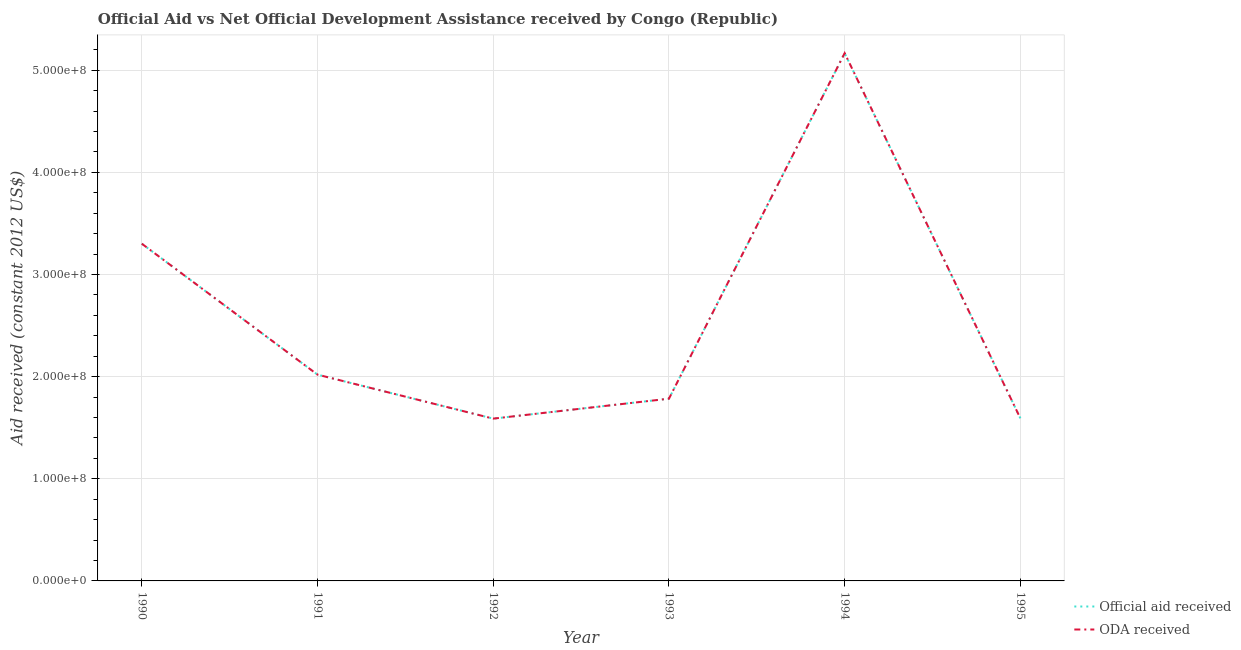Does the line corresponding to oda received intersect with the line corresponding to official aid received?
Ensure brevity in your answer.  Yes. Is the number of lines equal to the number of legend labels?
Offer a terse response. Yes. What is the official aid received in 1992?
Provide a succinct answer. 1.59e+08. Across all years, what is the maximum official aid received?
Keep it short and to the point. 5.17e+08. Across all years, what is the minimum oda received?
Your response must be concise. 1.59e+08. In which year was the official aid received maximum?
Keep it short and to the point. 1994. In which year was the official aid received minimum?
Provide a succinct answer. 1992. What is the total official aid received in the graph?
Ensure brevity in your answer.  1.55e+09. What is the difference between the oda received in 1990 and that in 1991?
Provide a short and direct response. 1.28e+08. What is the difference between the official aid received in 1993 and the oda received in 1990?
Offer a terse response. -1.52e+08. What is the average oda received per year?
Your response must be concise. 2.58e+08. In how many years, is the oda received greater than 300000000 US$?
Offer a terse response. 2. What is the ratio of the oda received in 1990 to that in 1993?
Your answer should be very brief. 1.85. Is the difference between the official aid received in 1990 and 1994 greater than the difference between the oda received in 1990 and 1994?
Offer a terse response. No. What is the difference between the highest and the second highest oda received?
Your answer should be compact. 1.87e+08. What is the difference between the highest and the lowest oda received?
Provide a succinct answer. 3.58e+08. In how many years, is the oda received greater than the average oda received taken over all years?
Your answer should be compact. 2. Is the official aid received strictly less than the oda received over the years?
Ensure brevity in your answer.  No. How many lines are there?
Offer a terse response. 2. Does the graph contain grids?
Offer a very short reply. Yes. How many legend labels are there?
Your answer should be compact. 2. What is the title of the graph?
Give a very brief answer. Official Aid vs Net Official Development Assistance received by Congo (Republic) . Does "Lower secondary rate" appear as one of the legend labels in the graph?
Ensure brevity in your answer.  No. What is the label or title of the Y-axis?
Provide a short and direct response. Aid received (constant 2012 US$). What is the Aid received (constant 2012 US$) in Official aid received in 1990?
Provide a short and direct response. 3.30e+08. What is the Aid received (constant 2012 US$) of ODA received in 1990?
Your response must be concise. 3.30e+08. What is the Aid received (constant 2012 US$) of Official aid received in 1991?
Provide a short and direct response. 2.02e+08. What is the Aid received (constant 2012 US$) of ODA received in 1991?
Keep it short and to the point. 2.02e+08. What is the Aid received (constant 2012 US$) of Official aid received in 1992?
Provide a short and direct response. 1.59e+08. What is the Aid received (constant 2012 US$) of ODA received in 1992?
Offer a terse response. 1.59e+08. What is the Aid received (constant 2012 US$) in Official aid received in 1993?
Provide a short and direct response. 1.78e+08. What is the Aid received (constant 2012 US$) of ODA received in 1993?
Make the answer very short. 1.78e+08. What is the Aid received (constant 2012 US$) of Official aid received in 1994?
Give a very brief answer. 5.17e+08. What is the Aid received (constant 2012 US$) of ODA received in 1994?
Ensure brevity in your answer.  5.17e+08. What is the Aid received (constant 2012 US$) in Official aid received in 1995?
Ensure brevity in your answer.  1.59e+08. What is the Aid received (constant 2012 US$) of ODA received in 1995?
Keep it short and to the point. 1.59e+08. Across all years, what is the maximum Aid received (constant 2012 US$) in Official aid received?
Your response must be concise. 5.17e+08. Across all years, what is the maximum Aid received (constant 2012 US$) in ODA received?
Provide a succinct answer. 5.17e+08. Across all years, what is the minimum Aid received (constant 2012 US$) of Official aid received?
Give a very brief answer. 1.59e+08. Across all years, what is the minimum Aid received (constant 2012 US$) in ODA received?
Make the answer very short. 1.59e+08. What is the total Aid received (constant 2012 US$) in Official aid received in the graph?
Offer a terse response. 1.55e+09. What is the total Aid received (constant 2012 US$) in ODA received in the graph?
Ensure brevity in your answer.  1.55e+09. What is the difference between the Aid received (constant 2012 US$) of Official aid received in 1990 and that in 1991?
Keep it short and to the point. 1.28e+08. What is the difference between the Aid received (constant 2012 US$) in ODA received in 1990 and that in 1991?
Ensure brevity in your answer.  1.28e+08. What is the difference between the Aid received (constant 2012 US$) in Official aid received in 1990 and that in 1992?
Offer a terse response. 1.71e+08. What is the difference between the Aid received (constant 2012 US$) in ODA received in 1990 and that in 1992?
Offer a terse response. 1.71e+08. What is the difference between the Aid received (constant 2012 US$) of Official aid received in 1990 and that in 1993?
Provide a succinct answer. 1.52e+08. What is the difference between the Aid received (constant 2012 US$) of ODA received in 1990 and that in 1993?
Provide a succinct answer. 1.52e+08. What is the difference between the Aid received (constant 2012 US$) in Official aid received in 1990 and that in 1994?
Your answer should be compact. -1.87e+08. What is the difference between the Aid received (constant 2012 US$) in ODA received in 1990 and that in 1994?
Your answer should be very brief. -1.87e+08. What is the difference between the Aid received (constant 2012 US$) in Official aid received in 1990 and that in 1995?
Give a very brief answer. 1.71e+08. What is the difference between the Aid received (constant 2012 US$) of ODA received in 1990 and that in 1995?
Your answer should be very brief. 1.71e+08. What is the difference between the Aid received (constant 2012 US$) of Official aid received in 1991 and that in 1992?
Make the answer very short. 4.31e+07. What is the difference between the Aid received (constant 2012 US$) in ODA received in 1991 and that in 1992?
Offer a very short reply. 4.31e+07. What is the difference between the Aid received (constant 2012 US$) of Official aid received in 1991 and that in 1993?
Provide a short and direct response. 2.35e+07. What is the difference between the Aid received (constant 2012 US$) in ODA received in 1991 and that in 1993?
Give a very brief answer. 2.35e+07. What is the difference between the Aid received (constant 2012 US$) in Official aid received in 1991 and that in 1994?
Offer a very short reply. -3.15e+08. What is the difference between the Aid received (constant 2012 US$) of ODA received in 1991 and that in 1994?
Provide a succinct answer. -3.15e+08. What is the difference between the Aid received (constant 2012 US$) in Official aid received in 1991 and that in 1995?
Provide a short and direct response. 4.28e+07. What is the difference between the Aid received (constant 2012 US$) of ODA received in 1991 and that in 1995?
Ensure brevity in your answer.  4.28e+07. What is the difference between the Aid received (constant 2012 US$) of Official aid received in 1992 and that in 1993?
Keep it short and to the point. -1.95e+07. What is the difference between the Aid received (constant 2012 US$) of ODA received in 1992 and that in 1993?
Keep it short and to the point. -1.95e+07. What is the difference between the Aid received (constant 2012 US$) of Official aid received in 1992 and that in 1994?
Keep it short and to the point. -3.58e+08. What is the difference between the Aid received (constant 2012 US$) in ODA received in 1992 and that in 1994?
Make the answer very short. -3.58e+08. What is the difference between the Aid received (constant 2012 US$) of Official aid received in 1992 and that in 1995?
Your answer should be compact. -2.90e+05. What is the difference between the Aid received (constant 2012 US$) in Official aid received in 1993 and that in 1994?
Provide a short and direct response. -3.38e+08. What is the difference between the Aid received (constant 2012 US$) of ODA received in 1993 and that in 1994?
Keep it short and to the point. -3.38e+08. What is the difference between the Aid received (constant 2012 US$) in Official aid received in 1993 and that in 1995?
Your answer should be very brief. 1.92e+07. What is the difference between the Aid received (constant 2012 US$) of ODA received in 1993 and that in 1995?
Ensure brevity in your answer.  1.92e+07. What is the difference between the Aid received (constant 2012 US$) in Official aid received in 1994 and that in 1995?
Ensure brevity in your answer.  3.58e+08. What is the difference between the Aid received (constant 2012 US$) in ODA received in 1994 and that in 1995?
Provide a succinct answer. 3.58e+08. What is the difference between the Aid received (constant 2012 US$) in Official aid received in 1990 and the Aid received (constant 2012 US$) in ODA received in 1991?
Keep it short and to the point. 1.28e+08. What is the difference between the Aid received (constant 2012 US$) of Official aid received in 1990 and the Aid received (constant 2012 US$) of ODA received in 1992?
Make the answer very short. 1.71e+08. What is the difference between the Aid received (constant 2012 US$) in Official aid received in 1990 and the Aid received (constant 2012 US$) in ODA received in 1993?
Give a very brief answer. 1.52e+08. What is the difference between the Aid received (constant 2012 US$) in Official aid received in 1990 and the Aid received (constant 2012 US$) in ODA received in 1994?
Make the answer very short. -1.87e+08. What is the difference between the Aid received (constant 2012 US$) in Official aid received in 1990 and the Aid received (constant 2012 US$) in ODA received in 1995?
Ensure brevity in your answer.  1.71e+08. What is the difference between the Aid received (constant 2012 US$) in Official aid received in 1991 and the Aid received (constant 2012 US$) in ODA received in 1992?
Ensure brevity in your answer.  4.31e+07. What is the difference between the Aid received (constant 2012 US$) in Official aid received in 1991 and the Aid received (constant 2012 US$) in ODA received in 1993?
Your answer should be very brief. 2.35e+07. What is the difference between the Aid received (constant 2012 US$) of Official aid received in 1991 and the Aid received (constant 2012 US$) of ODA received in 1994?
Your answer should be very brief. -3.15e+08. What is the difference between the Aid received (constant 2012 US$) in Official aid received in 1991 and the Aid received (constant 2012 US$) in ODA received in 1995?
Offer a very short reply. 4.28e+07. What is the difference between the Aid received (constant 2012 US$) of Official aid received in 1992 and the Aid received (constant 2012 US$) of ODA received in 1993?
Give a very brief answer. -1.95e+07. What is the difference between the Aid received (constant 2012 US$) of Official aid received in 1992 and the Aid received (constant 2012 US$) of ODA received in 1994?
Your answer should be very brief. -3.58e+08. What is the difference between the Aid received (constant 2012 US$) of Official aid received in 1993 and the Aid received (constant 2012 US$) of ODA received in 1994?
Offer a terse response. -3.38e+08. What is the difference between the Aid received (constant 2012 US$) in Official aid received in 1993 and the Aid received (constant 2012 US$) in ODA received in 1995?
Ensure brevity in your answer.  1.92e+07. What is the difference between the Aid received (constant 2012 US$) of Official aid received in 1994 and the Aid received (constant 2012 US$) of ODA received in 1995?
Your answer should be very brief. 3.58e+08. What is the average Aid received (constant 2012 US$) of Official aid received per year?
Make the answer very short. 2.58e+08. What is the average Aid received (constant 2012 US$) of ODA received per year?
Make the answer very short. 2.58e+08. In the year 1990, what is the difference between the Aid received (constant 2012 US$) in Official aid received and Aid received (constant 2012 US$) in ODA received?
Provide a succinct answer. 0. In the year 1993, what is the difference between the Aid received (constant 2012 US$) of Official aid received and Aid received (constant 2012 US$) of ODA received?
Provide a succinct answer. 0. What is the ratio of the Aid received (constant 2012 US$) in Official aid received in 1990 to that in 1991?
Ensure brevity in your answer.  1.63. What is the ratio of the Aid received (constant 2012 US$) in ODA received in 1990 to that in 1991?
Keep it short and to the point. 1.63. What is the ratio of the Aid received (constant 2012 US$) in Official aid received in 1990 to that in 1992?
Your response must be concise. 2.08. What is the ratio of the Aid received (constant 2012 US$) of ODA received in 1990 to that in 1992?
Keep it short and to the point. 2.08. What is the ratio of the Aid received (constant 2012 US$) of Official aid received in 1990 to that in 1993?
Keep it short and to the point. 1.85. What is the ratio of the Aid received (constant 2012 US$) in ODA received in 1990 to that in 1993?
Provide a short and direct response. 1.85. What is the ratio of the Aid received (constant 2012 US$) of Official aid received in 1990 to that in 1994?
Provide a succinct answer. 0.64. What is the ratio of the Aid received (constant 2012 US$) in ODA received in 1990 to that in 1994?
Give a very brief answer. 0.64. What is the ratio of the Aid received (constant 2012 US$) in Official aid received in 1990 to that in 1995?
Give a very brief answer. 2.07. What is the ratio of the Aid received (constant 2012 US$) in ODA received in 1990 to that in 1995?
Provide a succinct answer. 2.07. What is the ratio of the Aid received (constant 2012 US$) of Official aid received in 1991 to that in 1992?
Give a very brief answer. 1.27. What is the ratio of the Aid received (constant 2012 US$) of ODA received in 1991 to that in 1992?
Your answer should be very brief. 1.27. What is the ratio of the Aid received (constant 2012 US$) of Official aid received in 1991 to that in 1993?
Offer a very short reply. 1.13. What is the ratio of the Aid received (constant 2012 US$) of ODA received in 1991 to that in 1993?
Ensure brevity in your answer.  1.13. What is the ratio of the Aid received (constant 2012 US$) of Official aid received in 1991 to that in 1994?
Offer a terse response. 0.39. What is the ratio of the Aid received (constant 2012 US$) of ODA received in 1991 to that in 1994?
Give a very brief answer. 0.39. What is the ratio of the Aid received (constant 2012 US$) of Official aid received in 1991 to that in 1995?
Make the answer very short. 1.27. What is the ratio of the Aid received (constant 2012 US$) in ODA received in 1991 to that in 1995?
Provide a succinct answer. 1.27. What is the ratio of the Aid received (constant 2012 US$) of Official aid received in 1992 to that in 1993?
Make the answer very short. 0.89. What is the ratio of the Aid received (constant 2012 US$) in ODA received in 1992 to that in 1993?
Give a very brief answer. 0.89. What is the ratio of the Aid received (constant 2012 US$) of Official aid received in 1992 to that in 1994?
Provide a succinct answer. 0.31. What is the ratio of the Aid received (constant 2012 US$) of ODA received in 1992 to that in 1994?
Make the answer very short. 0.31. What is the ratio of the Aid received (constant 2012 US$) of ODA received in 1992 to that in 1995?
Offer a very short reply. 1. What is the ratio of the Aid received (constant 2012 US$) in Official aid received in 1993 to that in 1994?
Give a very brief answer. 0.35. What is the ratio of the Aid received (constant 2012 US$) of ODA received in 1993 to that in 1994?
Your response must be concise. 0.35. What is the ratio of the Aid received (constant 2012 US$) in Official aid received in 1993 to that in 1995?
Your answer should be very brief. 1.12. What is the ratio of the Aid received (constant 2012 US$) in ODA received in 1993 to that in 1995?
Offer a very short reply. 1.12. What is the ratio of the Aid received (constant 2012 US$) in Official aid received in 1994 to that in 1995?
Your answer should be very brief. 3.25. What is the ratio of the Aid received (constant 2012 US$) in ODA received in 1994 to that in 1995?
Offer a terse response. 3.25. What is the difference between the highest and the second highest Aid received (constant 2012 US$) in Official aid received?
Your response must be concise. 1.87e+08. What is the difference between the highest and the second highest Aid received (constant 2012 US$) of ODA received?
Provide a short and direct response. 1.87e+08. What is the difference between the highest and the lowest Aid received (constant 2012 US$) in Official aid received?
Offer a very short reply. 3.58e+08. What is the difference between the highest and the lowest Aid received (constant 2012 US$) of ODA received?
Provide a succinct answer. 3.58e+08. 